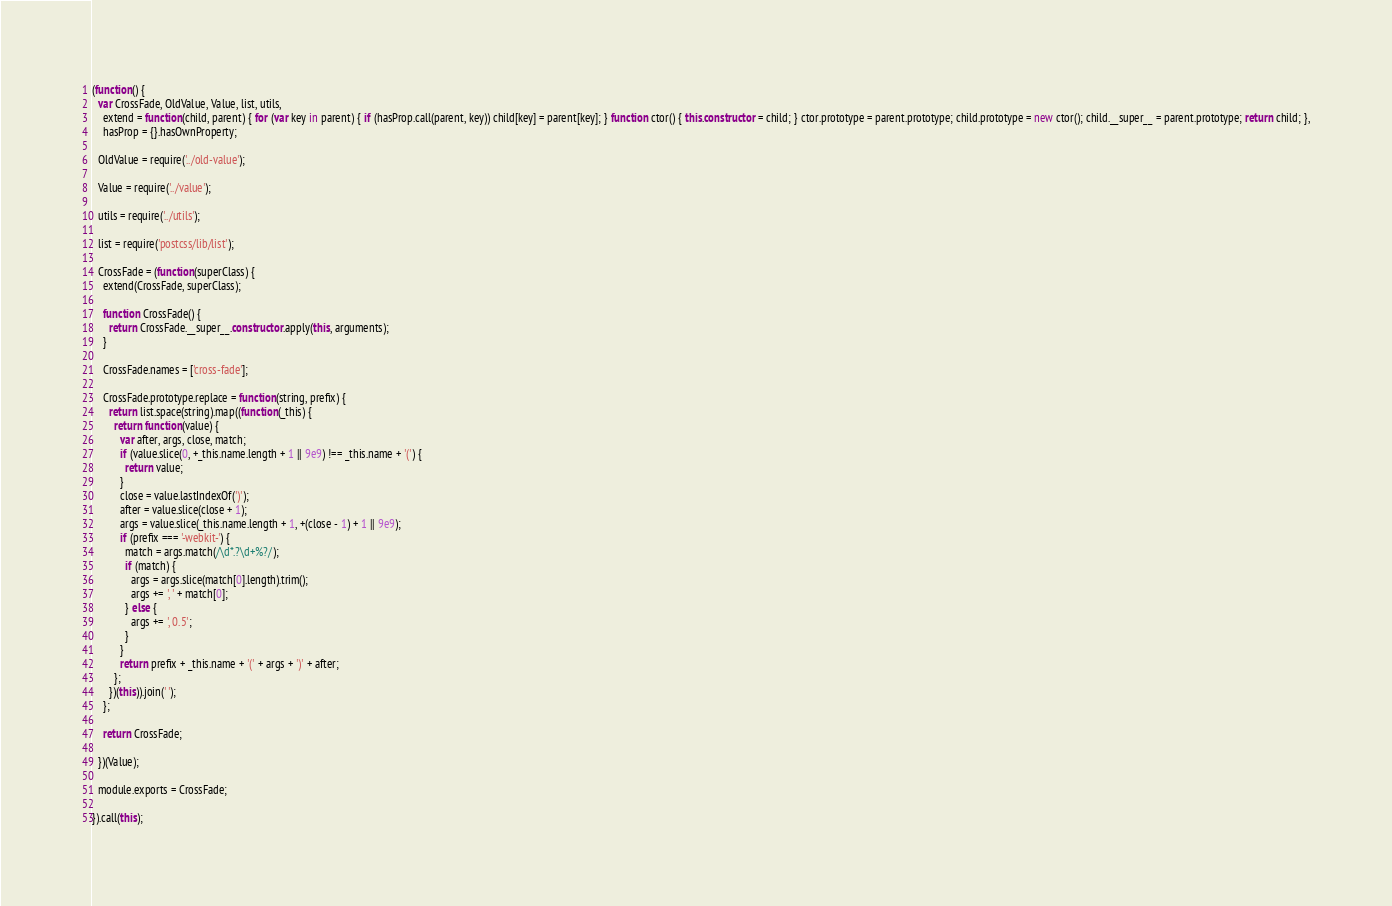Convert code to text. <code><loc_0><loc_0><loc_500><loc_500><_JavaScript_>(function() {
  var CrossFade, OldValue, Value, list, utils,
    extend = function(child, parent) { for (var key in parent) { if (hasProp.call(parent, key)) child[key] = parent[key]; } function ctor() { this.constructor = child; } ctor.prototype = parent.prototype; child.prototype = new ctor(); child.__super__ = parent.prototype; return child; },
    hasProp = {}.hasOwnProperty;

  OldValue = require('../old-value');

  Value = require('../value');

  utils = require('../utils');

  list = require('postcss/lib/list');

  CrossFade = (function(superClass) {
    extend(CrossFade, superClass);

    function CrossFade() {
      return CrossFade.__super__.constructor.apply(this, arguments);
    }

    CrossFade.names = ['cross-fade'];

    CrossFade.prototype.replace = function(string, prefix) {
      return list.space(string).map((function(_this) {
        return function(value) {
          var after, args, close, match;
          if (value.slice(0, +_this.name.length + 1 || 9e9) !== _this.name + '(') {
            return value;
          }
          close = value.lastIndexOf(')');
          after = value.slice(close + 1);
          args = value.slice(_this.name.length + 1, +(close - 1) + 1 || 9e9);
          if (prefix === '-webkit-') {
            match = args.match(/\d*.?\d+%?/);
            if (match) {
              args = args.slice(match[0].length).trim();
              args += ', ' + match[0];
            } else {
              args += ', 0.5';
            }
          }
          return prefix + _this.name + '(' + args + ')' + after;
        };
      })(this)).join(' ');
    };

    return CrossFade;

  })(Value);

  module.exports = CrossFade;

}).call(this);
</code> 